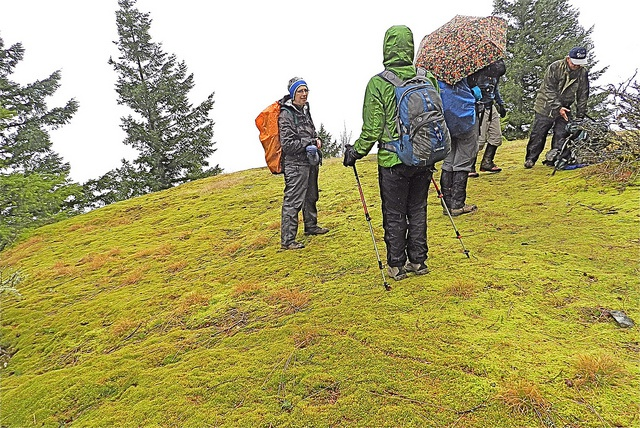Describe the objects in this image and their specific colors. I can see people in white, black, gray, darkgray, and olive tones, people in white, gray, black, and darkgray tones, backpack in white, gray, darkgray, and black tones, umbrella in white, darkgray, gray, and tan tones, and people in white, gray, black, and darkgray tones in this image. 